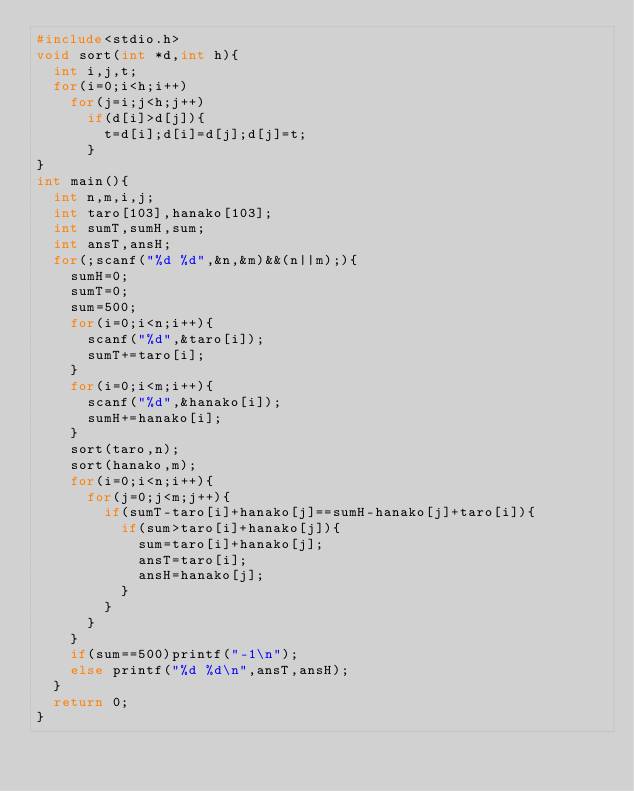Convert code to text. <code><loc_0><loc_0><loc_500><loc_500><_C_>#include<stdio.h>
void sort(int *d,int h){
	int i,j,t;
	for(i=0;i<h;i++)
		for(j=i;j<h;j++)
			if(d[i]>d[j]){
				t=d[i];d[i]=d[j];d[j]=t;
			}
}
int main(){
	int n,m,i,j;
	int taro[103],hanako[103];
	int sumT,sumH,sum;
	int ansT,ansH;
	for(;scanf("%d %d",&n,&m)&&(n||m);){
		sumH=0;
		sumT=0;
		sum=500;
		for(i=0;i<n;i++){
			scanf("%d",&taro[i]);
			sumT+=taro[i];
		}
		for(i=0;i<m;i++){
			scanf("%d",&hanako[i]);
			sumH+=hanako[i];
		}
		sort(taro,n);
		sort(hanako,m);
		for(i=0;i<n;i++){
			for(j=0;j<m;j++){
				if(sumT-taro[i]+hanako[j]==sumH-hanako[j]+taro[i]){
					if(sum>taro[i]+hanako[j]){
						sum=taro[i]+hanako[j];
						ansT=taro[i];
						ansH=hanako[j];
					}
				}
			}
		}
		if(sum==500)printf("-1\n");
		else printf("%d %d\n",ansT,ansH);
	}
	return 0;
}</code> 